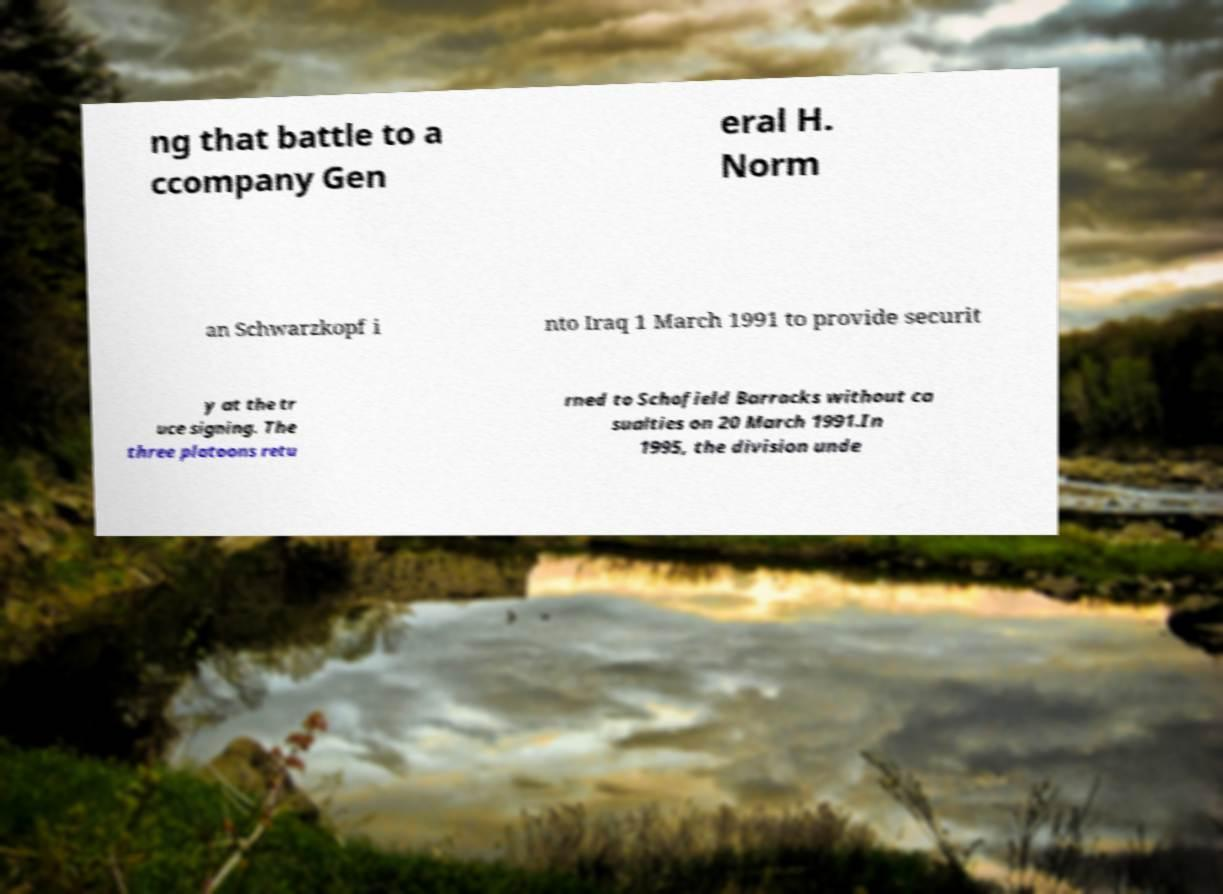For documentation purposes, I need the text within this image transcribed. Could you provide that? ng that battle to a ccompany Gen eral H. Norm an Schwarzkopf i nto Iraq 1 March 1991 to provide securit y at the tr uce signing. The three platoons retu rned to Schofield Barracks without ca sualties on 20 March 1991.In 1995, the division unde 